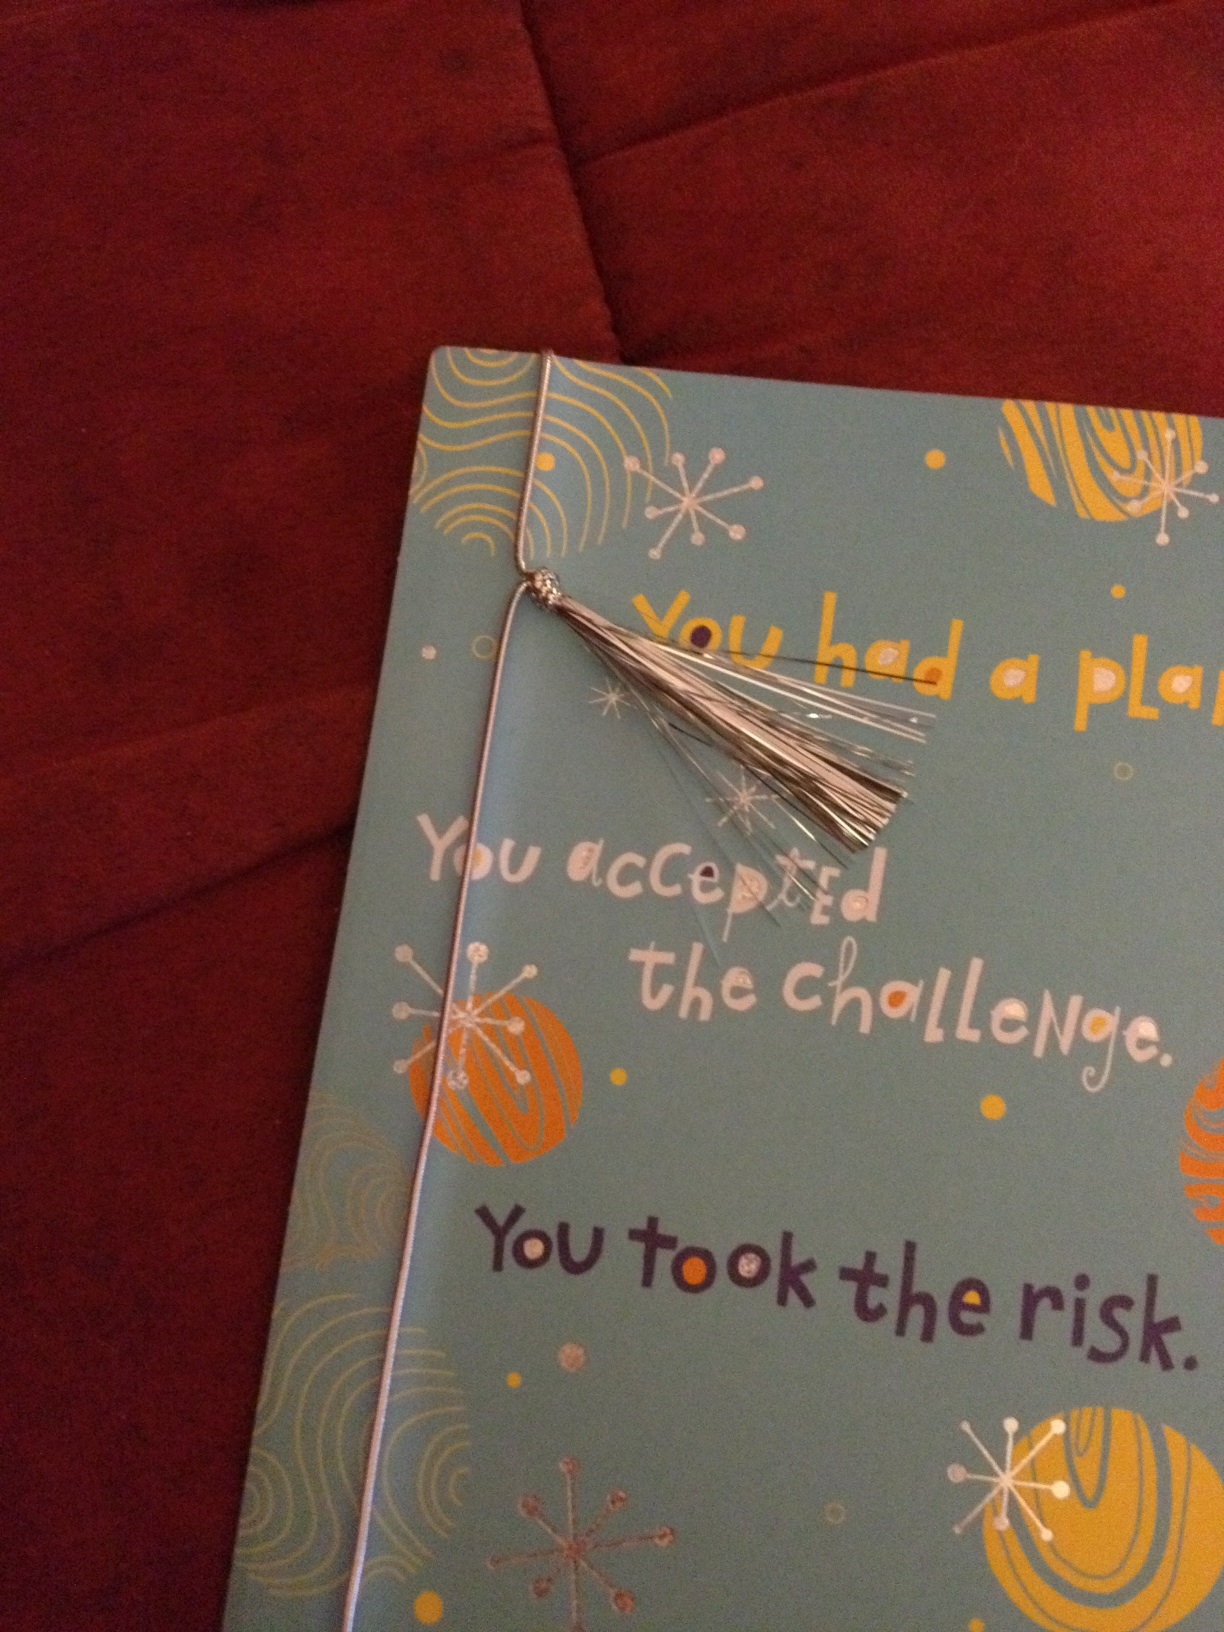What is the significance of the silver tassel on the card? The silver tassel on the card adds a touch of celebration and elegance. It can symbolize success, accomplishment, and festivity, making the card feel more special and personalized. Tassels are often associated with graduation caps, suggesting achievement and a milestone reached. If you could personify this card, what kind of personality would it have? If this card were a person, it would have a bold, encouraging, and positive personality. It would be the kind of person who always stands by you, cheering you on through challenges and celebrating your victories. This individual would be optimistic, supportive, and full of vibrant energy. Imagine a scenario where someone gives this card to an astronaut returning from a successful space mission. How would the astronaut react? Upon receiving this card, the astronaut would feel deeply appreciated and acknowledged. The message would resonate with their journey, highlighting the meticulous planning, acceptance of risks, and the courage it took to venture into the unknown. They would smile, feeling a sense of validation and joy, knowing that their hard work and dedication did not go unnoticed. The silver tassel would remind them of the challenges they overcame and the celebratory nature of their successful mission. 